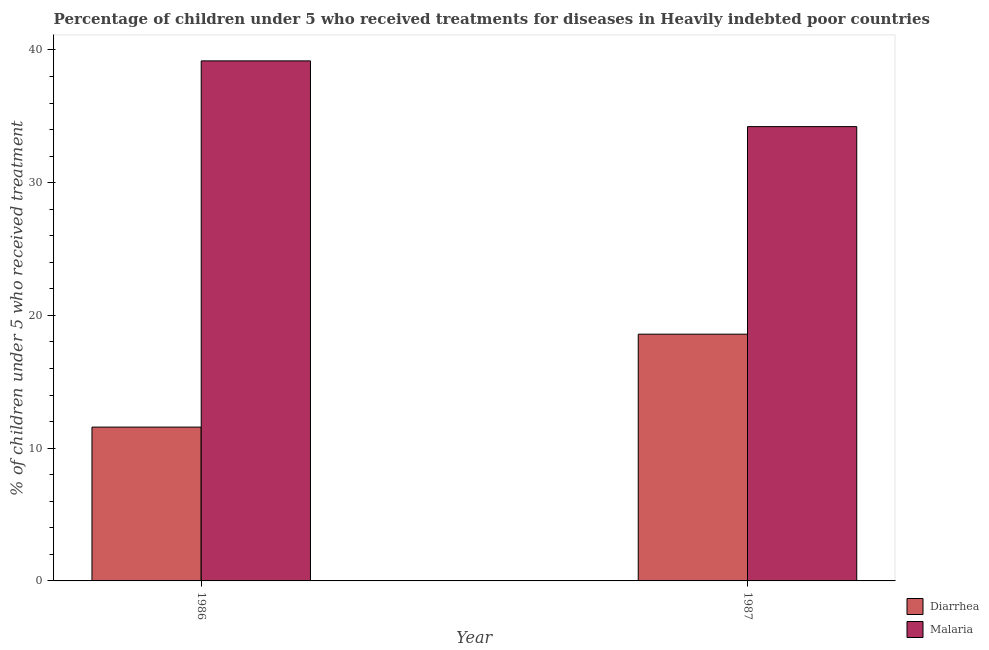How many different coloured bars are there?
Offer a terse response. 2. Are the number of bars per tick equal to the number of legend labels?
Your answer should be compact. Yes. Are the number of bars on each tick of the X-axis equal?
Provide a succinct answer. Yes. How many bars are there on the 1st tick from the left?
Give a very brief answer. 2. What is the label of the 2nd group of bars from the left?
Provide a short and direct response. 1987. In how many cases, is the number of bars for a given year not equal to the number of legend labels?
Your answer should be compact. 0. What is the percentage of children who received treatment for malaria in 1987?
Ensure brevity in your answer.  34.22. Across all years, what is the maximum percentage of children who received treatment for malaria?
Offer a terse response. 39.18. Across all years, what is the minimum percentage of children who received treatment for diarrhoea?
Ensure brevity in your answer.  11.59. In which year was the percentage of children who received treatment for malaria maximum?
Your answer should be compact. 1986. What is the total percentage of children who received treatment for malaria in the graph?
Offer a very short reply. 73.4. What is the difference between the percentage of children who received treatment for diarrhoea in 1986 and that in 1987?
Your answer should be compact. -7. What is the difference between the percentage of children who received treatment for diarrhoea in 1986 and the percentage of children who received treatment for malaria in 1987?
Provide a succinct answer. -7. What is the average percentage of children who received treatment for diarrhoea per year?
Provide a succinct answer. 15.09. In the year 1987, what is the difference between the percentage of children who received treatment for malaria and percentage of children who received treatment for diarrhoea?
Offer a very short reply. 0. In how many years, is the percentage of children who received treatment for diarrhoea greater than 8 %?
Keep it short and to the point. 2. What is the ratio of the percentage of children who received treatment for malaria in 1986 to that in 1987?
Keep it short and to the point. 1.14. Is the percentage of children who received treatment for malaria in 1986 less than that in 1987?
Your response must be concise. No. In how many years, is the percentage of children who received treatment for malaria greater than the average percentage of children who received treatment for malaria taken over all years?
Your answer should be very brief. 1. What does the 1st bar from the left in 1986 represents?
Your response must be concise. Diarrhea. What does the 2nd bar from the right in 1986 represents?
Your response must be concise. Diarrhea. Does the graph contain any zero values?
Ensure brevity in your answer.  No. Where does the legend appear in the graph?
Provide a succinct answer. Bottom right. What is the title of the graph?
Your answer should be very brief. Percentage of children under 5 who received treatments for diseases in Heavily indebted poor countries. Does "Under-five" appear as one of the legend labels in the graph?
Offer a very short reply. No. What is the label or title of the Y-axis?
Keep it short and to the point. % of children under 5 who received treatment. What is the % of children under 5 who received treatment of Diarrhea in 1986?
Provide a short and direct response. 11.59. What is the % of children under 5 who received treatment of Malaria in 1986?
Your response must be concise. 39.18. What is the % of children under 5 who received treatment of Diarrhea in 1987?
Provide a succinct answer. 18.59. What is the % of children under 5 who received treatment in Malaria in 1987?
Your response must be concise. 34.22. Across all years, what is the maximum % of children under 5 who received treatment in Diarrhea?
Provide a succinct answer. 18.59. Across all years, what is the maximum % of children under 5 who received treatment in Malaria?
Your answer should be compact. 39.18. Across all years, what is the minimum % of children under 5 who received treatment in Diarrhea?
Offer a terse response. 11.59. Across all years, what is the minimum % of children under 5 who received treatment of Malaria?
Your answer should be very brief. 34.22. What is the total % of children under 5 who received treatment in Diarrhea in the graph?
Give a very brief answer. 30.17. What is the total % of children under 5 who received treatment of Malaria in the graph?
Your answer should be very brief. 73.4. What is the difference between the % of children under 5 who received treatment of Diarrhea in 1986 and that in 1987?
Make the answer very short. -7. What is the difference between the % of children under 5 who received treatment of Malaria in 1986 and that in 1987?
Make the answer very short. 4.95. What is the difference between the % of children under 5 who received treatment in Diarrhea in 1986 and the % of children under 5 who received treatment in Malaria in 1987?
Provide a short and direct response. -22.64. What is the average % of children under 5 who received treatment in Diarrhea per year?
Offer a terse response. 15.09. What is the average % of children under 5 who received treatment of Malaria per year?
Provide a short and direct response. 36.7. In the year 1986, what is the difference between the % of children under 5 who received treatment of Diarrhea and % of children under 5 who received treatment of Malaria?
Ensure brevity in your answer.  -27.59. In the year 1987, what is the difference between the % of children under 5 who received treatment of Diarrhea and % of children under 5 who received treatment of Malaria?
Give a very brief answer. -15.64. What is the ratio of the % of children under 5 who received treatment in Diarrhea in 1986 to that in 1987?
Offer a terse response. 0.62. What is the ratio of the % of children under 5 who received treatment of Malaria in 1986 to that in 1987?
Offer a very short reply. 1.14. What is the difference between the highest and the second highest % of children under 5 who received treatment of Diarrhea?
Offer a terse response. 7. What is the difference between the highest and the second highest % of children under 5 who received treatment of Malaria?
Provide a succinct answer. 4.95. What is the difference between the highest and the lowest % of children under 5 who received treatment of Diarrhea?
Your answer should be compact. 7. What is the difference between the highest and the lowest % of children under 5 who received treatment of Malaria?
Your response must be concise. 4.95. 